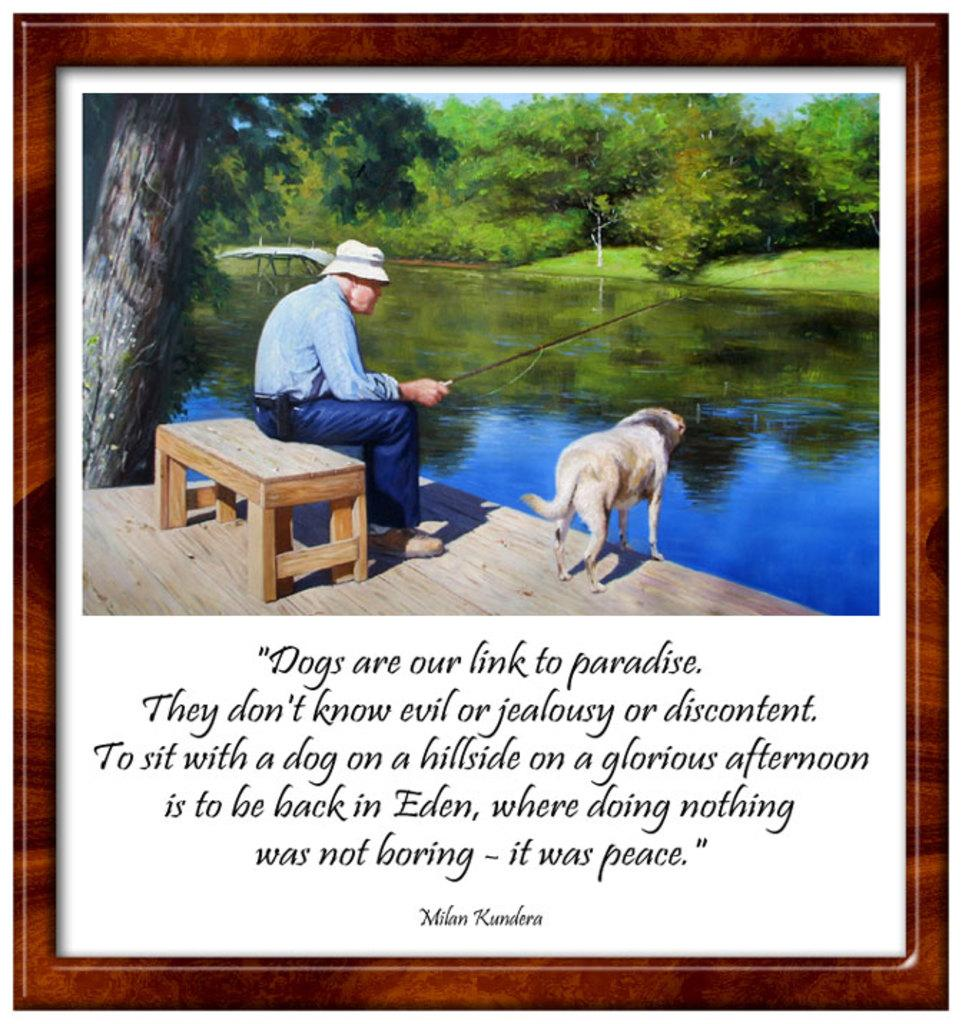Provide a one-sentence caption for the provided image. A Milan Kundera quote is written under a picture of a man fishing with his dog. 